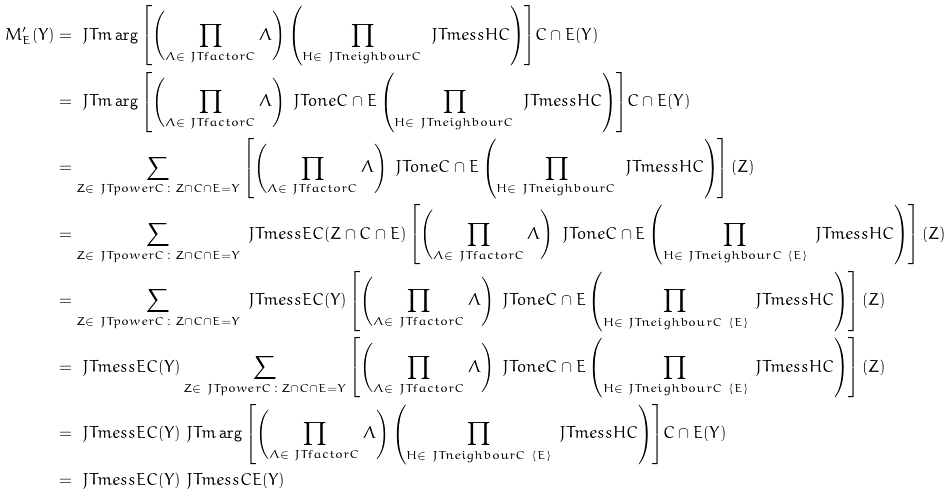Convert formula to latex. <formula><loc_0><loc_0><loc_500><loc_500>M ^ { \prime } _ { E } ( Y ) & = \ J T m \arg { \left [ \left ( \prod _ { \Lambda \in \ J T f a c t o r { C } } \Lambda \right ) \left ( \prod _ { H \in \ J T n e i g h b o u r { C } } \ J T m e s s { H } { C } \right ) \right ] } { C \cap E } ( Y ) \\ & = \ J T m \arg { \left [ \left ( \prod _ { \Lambda \in \ J T f a c t o r { C } } \Lambda \right ) \ J T o n e { C \cap E } \left ( \prod _ { H \in \ J T n e i g h b o u r { C } } \ J T m e s s { H } { C } \right ) \right ] } { C \cap E } ( Y ) \\ & = \sum _ { Z \in \ J T p o w e r { C } \colon Z \cap C \cap E = Y } \left [ \left ( \prod _ { \Lambda \in \ J T f a c t o r { C } } \Lambda \right ) \ J T o n e { C \cap E } \left ( \prod _ { H \in \ J T n e i g h b o u r { C } } \ J T m e s s { H } { C } \right ) \right ] ( Z ) \\ & = \sum _ { Z \in \ J T p o w e r { C } \colon Z \cap C \cap E = Y } \ J T m e s s { E } { C } ( Z \cap C \cap E ) \left [ \left ( \prod _ { \Lambda \in \ J T f a c t o r { C } } \Lambda \right ) \ J T o n e { C \cap E } \left ( \prod _ { H \in \ J T n e i g h b o u r { C } \ \{ E \} } \ J T m e s s { H } { C } \right ) \right ] ( Z ) \\ & = \sum _ { Z \in \ J T p o w e r { C } \colon Z \cap C \cap E = Y } \ J T m e s s { E } { C } ( Y ) \left [ \left ( \prod _ { \Lambda \in \ J T f a c t o r { C } } \Lambda \right ) \ J T o n e { C \cap E } \left ( \prod _ { H \in \ J T n e i g h b o u r { C } \ \{ E \} } \ J T m e s s { H } { C } \right ) \right ] ( Z ) \\ & = \ J T m e s s { E } { C } ( Y ) \sum _ { Z \in \ J T p o w e r { C } \colon Z \cap C \cap E = Y } \left [ \left ( \prod _ { \Lambda \in \ J T f a c t o r { C } } \Lambda \right ) \ J T o n e { C \cap E } \left ( \prod _ { H \in \ J T n e i g h b o u r { C } \ \{ E \} } \ J T m e s s { H } { C } \right ) \right ] ( Z ) \\ & = \ J T m e s s { E } { C } ( Y ) \ J T m \arg { \left [ \left ( \prod _ { \Lambda \in \ J T f a c t o r { C } } \Lambda \right ) \left ( \prod _ { H \in \ J T n e i g h b o u r { C } \ \{ E \} } \ J T m e s s { H } { C } \right ) \right ] } { C \cap E } ( Y ) \\ & = \ J T m e s s { E } { C } ( Y ) \ J T m e s s { C } { E } ( Y )</formula> 